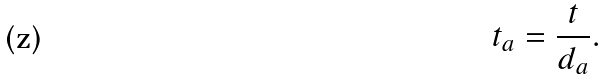<formula> <loc_0><loc_0><loc_500><loc_500>t _ { a } = \frac { t } { d _ { a } } .</formula> 